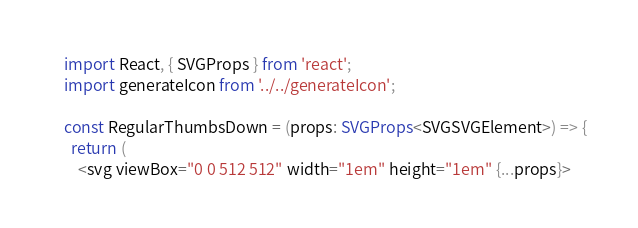<code> <loc_0><loc_0><loc_500><loc_500><_TypeScript_>import React, { SVGProps } from 'react';
import generateIcon from '../../generateIcon';

const RegularThumbsDown = (props: SVGProps<SVGSVGElement>) => {
  return (
    <svg viewBox="0 0 512 512" width="1em" height="1em" {...props}></code> 